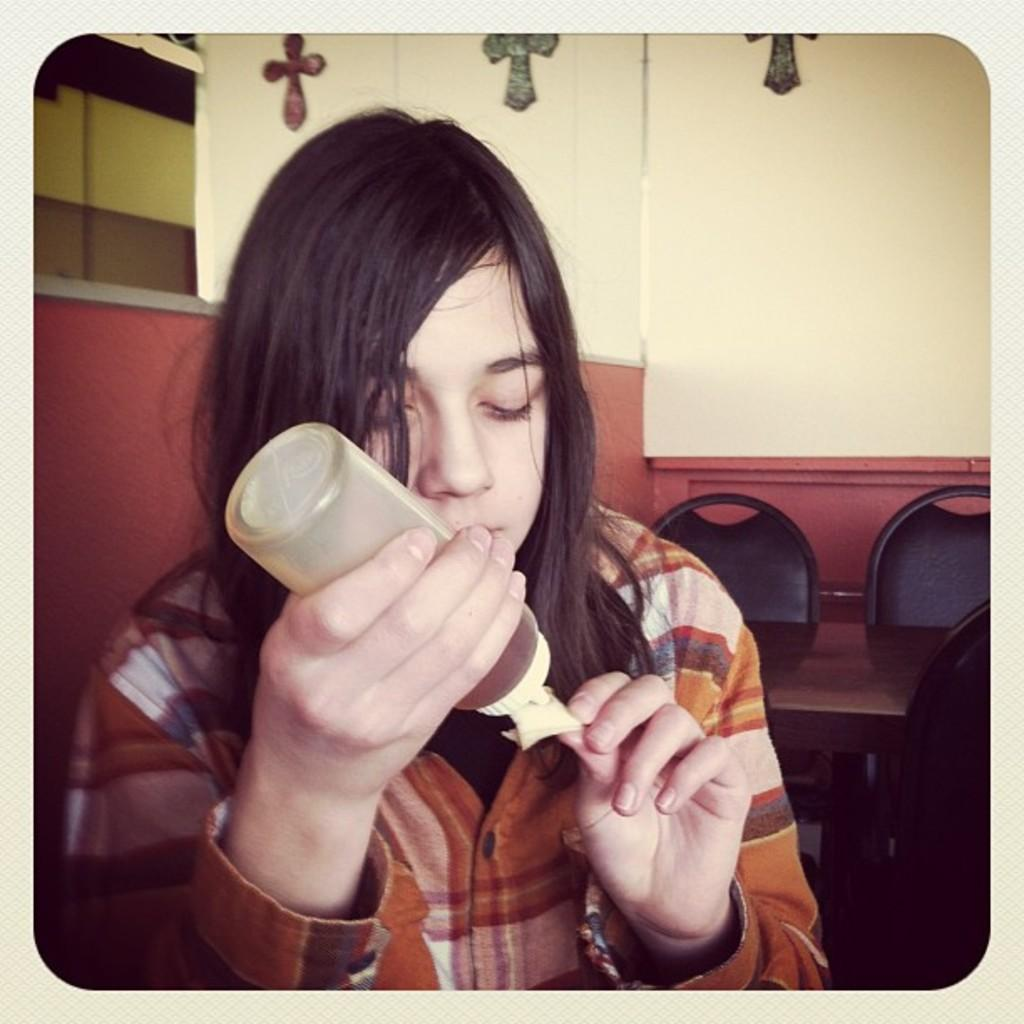Who is the main subject in the image? There is a lady in the center of the image. What is the lady holding in her hand? The lady is holding a bottle in her hand. What can be seen in the background of the image? There is a wall, chairs, and a table in the background of the image. Can you see a snake slithering on the table in the image? No, there is no snake present in the image. Is the lady's father sitting on one of the chairs in the background? There is no information about the lady's father or any other people in the image, so we cannot determine if he is sitting on a chair. 